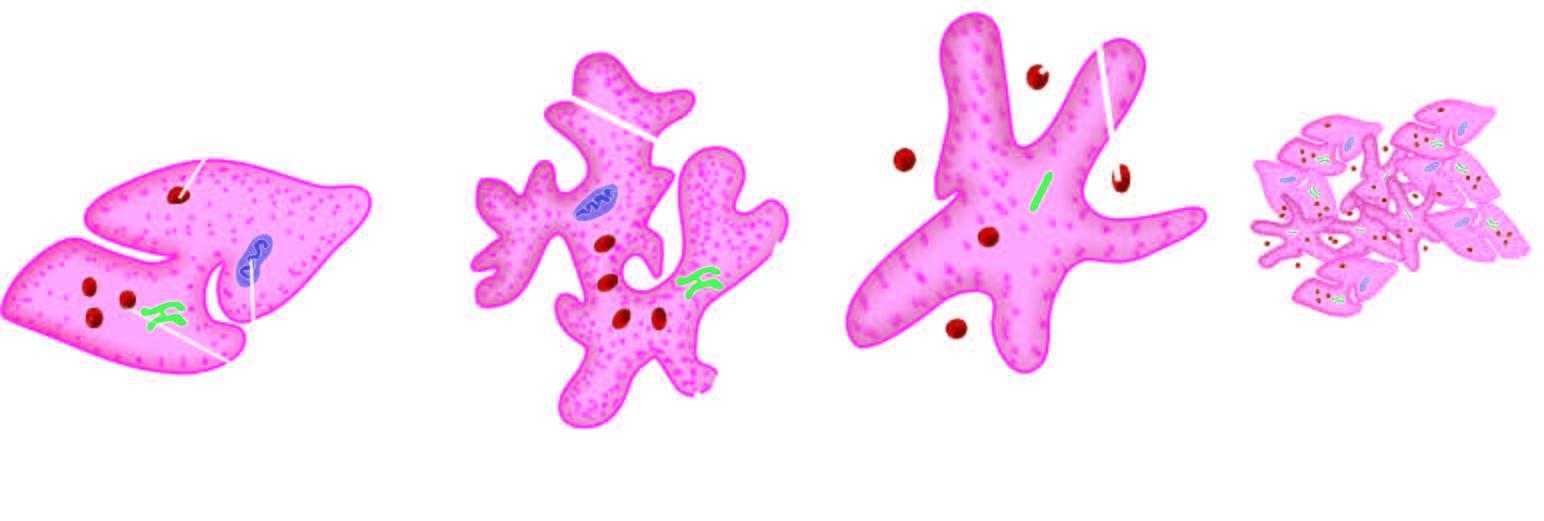what does platelet aggregation form?
Answer the question using a single word or phrase. Tight plug 